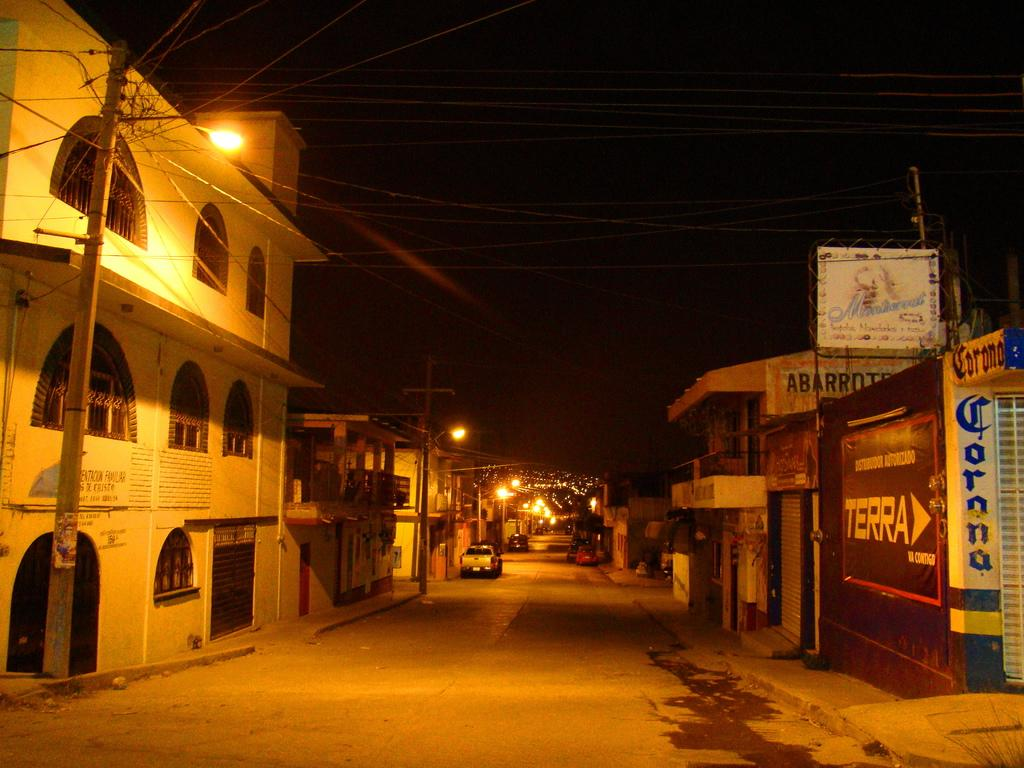What type of structures can be seen on both sides of the image? There are buildings on both sides of the image. What else can be seen in the image besides the buildings? There are electric poles and vehicles parked in front of the buildings. What is the main feature in the middle of the image? There is a road in the middle of the image. Can you hear the uncle playing the guitar during the rainstorm in the image? There is no uncle or guitar present in the image, nor is there any indication of a rainstorm. 